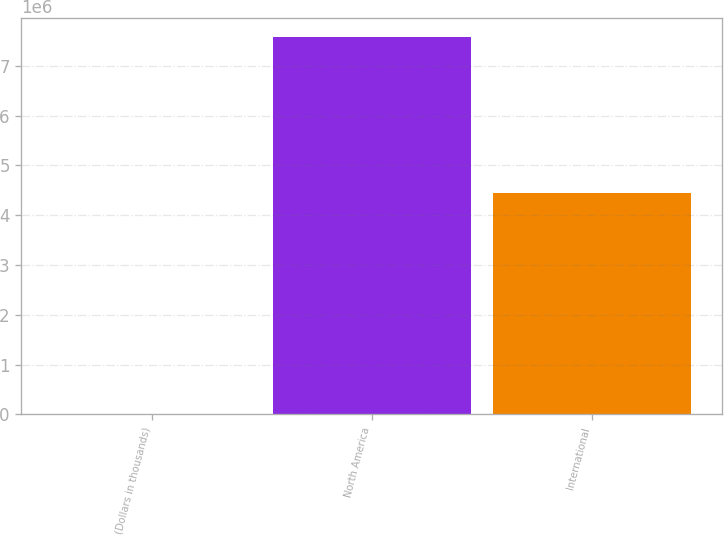Convert chart to OTSL. <chart><loc_0><loc_0><loc_500><loc_500><bar_chart><fcel>(Dollars in thousands)<fcel>North America<fcel>International<nl><fcel>2017<fcel>7.58569e+06<fcel>4.44362e+06<nl></chart> 